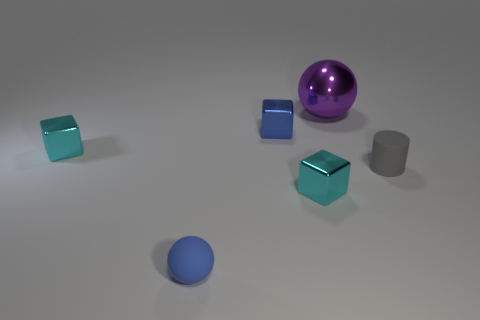Subtract all cyan blocks. How many blocks are left? 1 Subtract 0 brown cubes. How many objects are left? 6 Subtract all cylinders. How many objects are left? 5 Subtract all red blocks. Subtract all cyan cylinders. How many blocks are left? 3 Subtract all red cylinders. How many purple blocks are left? 0 Subtract all tiny gray metal blocks. Subtract all balls. How many objects are left? 4 Add 3 tiny cyan metal objects. How many tiny cyan metal objects are left? 5 Add 3 purple things. How many purple things exist? 4 Add 2 big metal spheres. How many objects exist? 8 Subtract all blue spheres. How many spheres are left? 1 